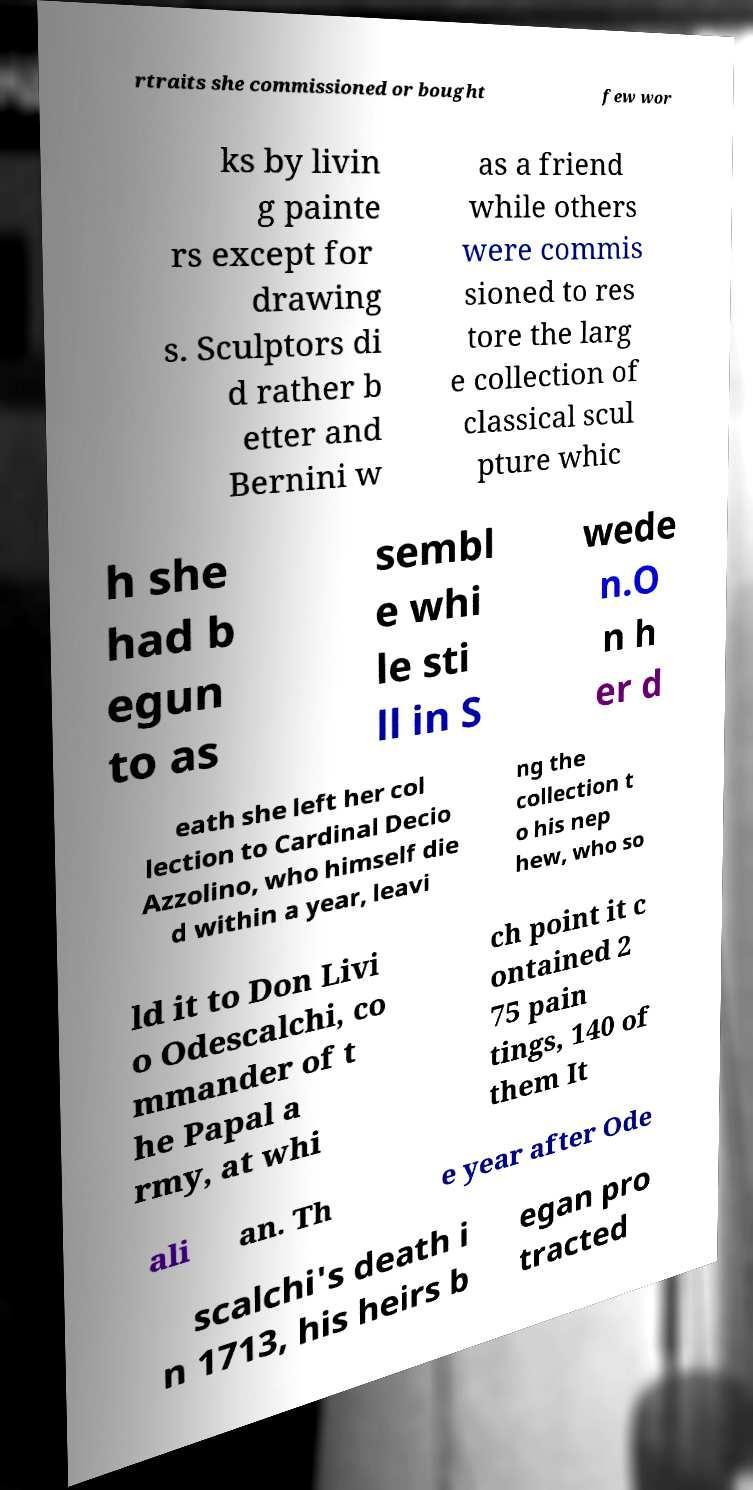There's text embedded in this image that I need extracted. Can you transcribe it verbatim? rtraits she commissioned or bought few wor ks by livin g painte rs except for drawing s. Sculptors di d rather b etter and Bernini w as a friend while others were commis sioned to res tore the larg e collection of classical scul pture whic h she had b egun to as sembl e whi le sti ll in S wede n.O n h er d eath she left her col lection to Cardinal Decio Azzolino, who himself die d within a year, leavi ng the collection t o his nep hew, who so ld it to Don Livi o Odescalchi, co mmander of t he Papal a rmy, at whi ch point it c ontained 2 75 pain tings, 140 of them It ali an. Th e year after Ode scalchi's death i n 1713, his heirs b egan pro tracted 